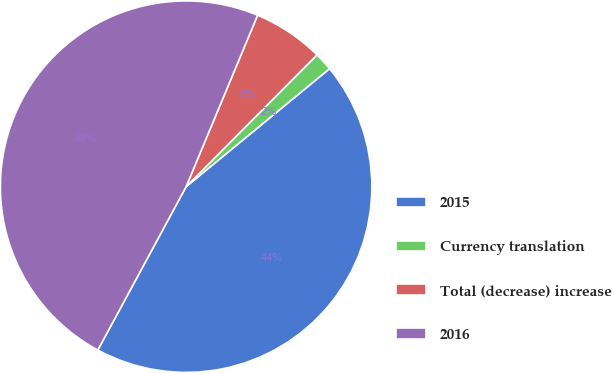Convert chart to OTSL. <chart><loc_0><loc_0><loc_500><loc_500><pie_chart><fcel>2015<fcel>Currency translation<fcel>Total (decrease) increase<fcel>2016<nl><fcel>43.84%<fcel>1.6%<fcel>6.16%<fcel>48.4%<nl></chart> 